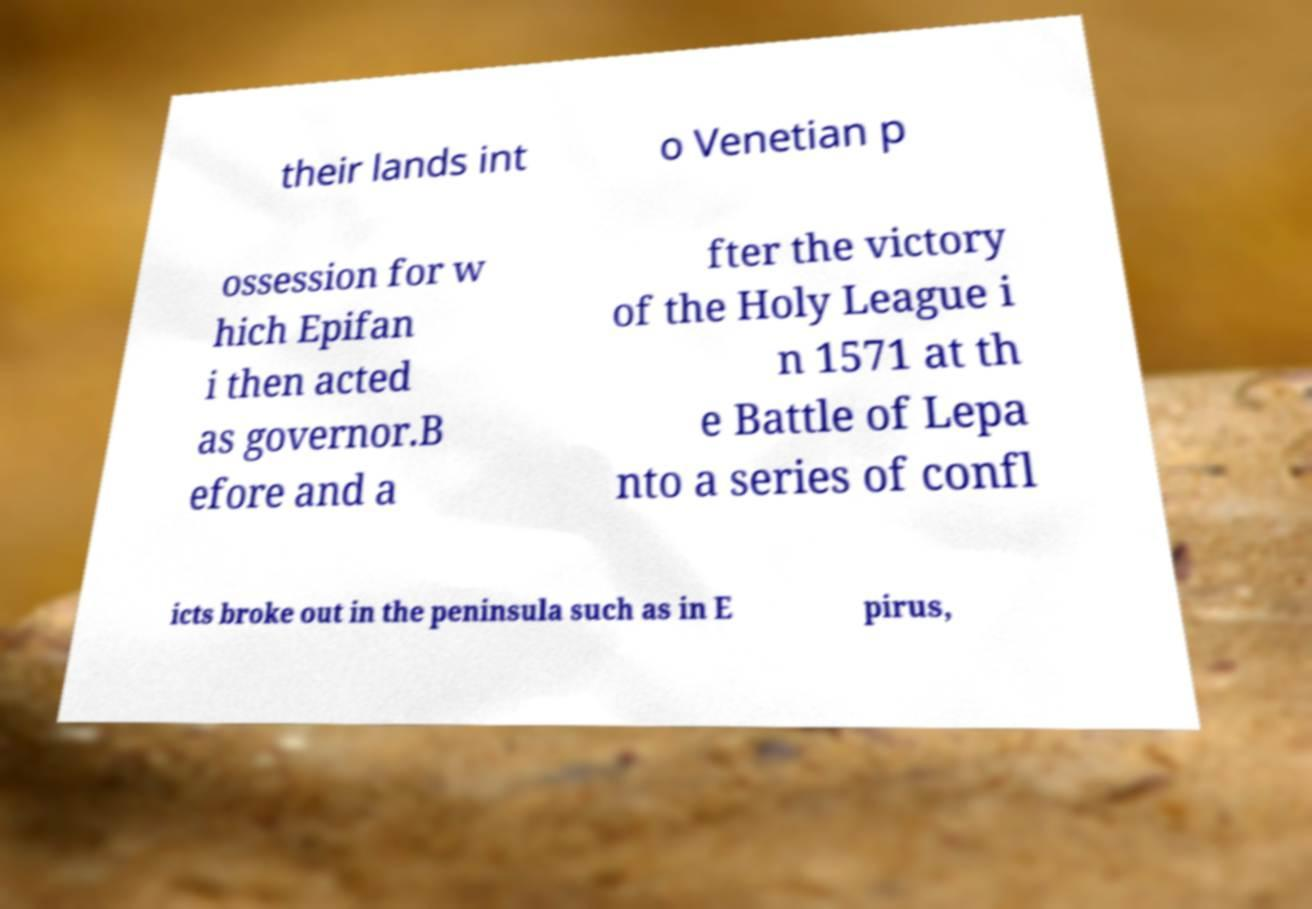There's text embedded in this image that I need extracted. Can you transcribe it verbatim? their lands int o Venetian p ossession for w hich Epifan i then acted as governor.B efore and a fter the victory of the Holy League i n 1571 at th e Battle of Lepa nto a series of confl icts broke out in the peninsula such as in E pirus, 